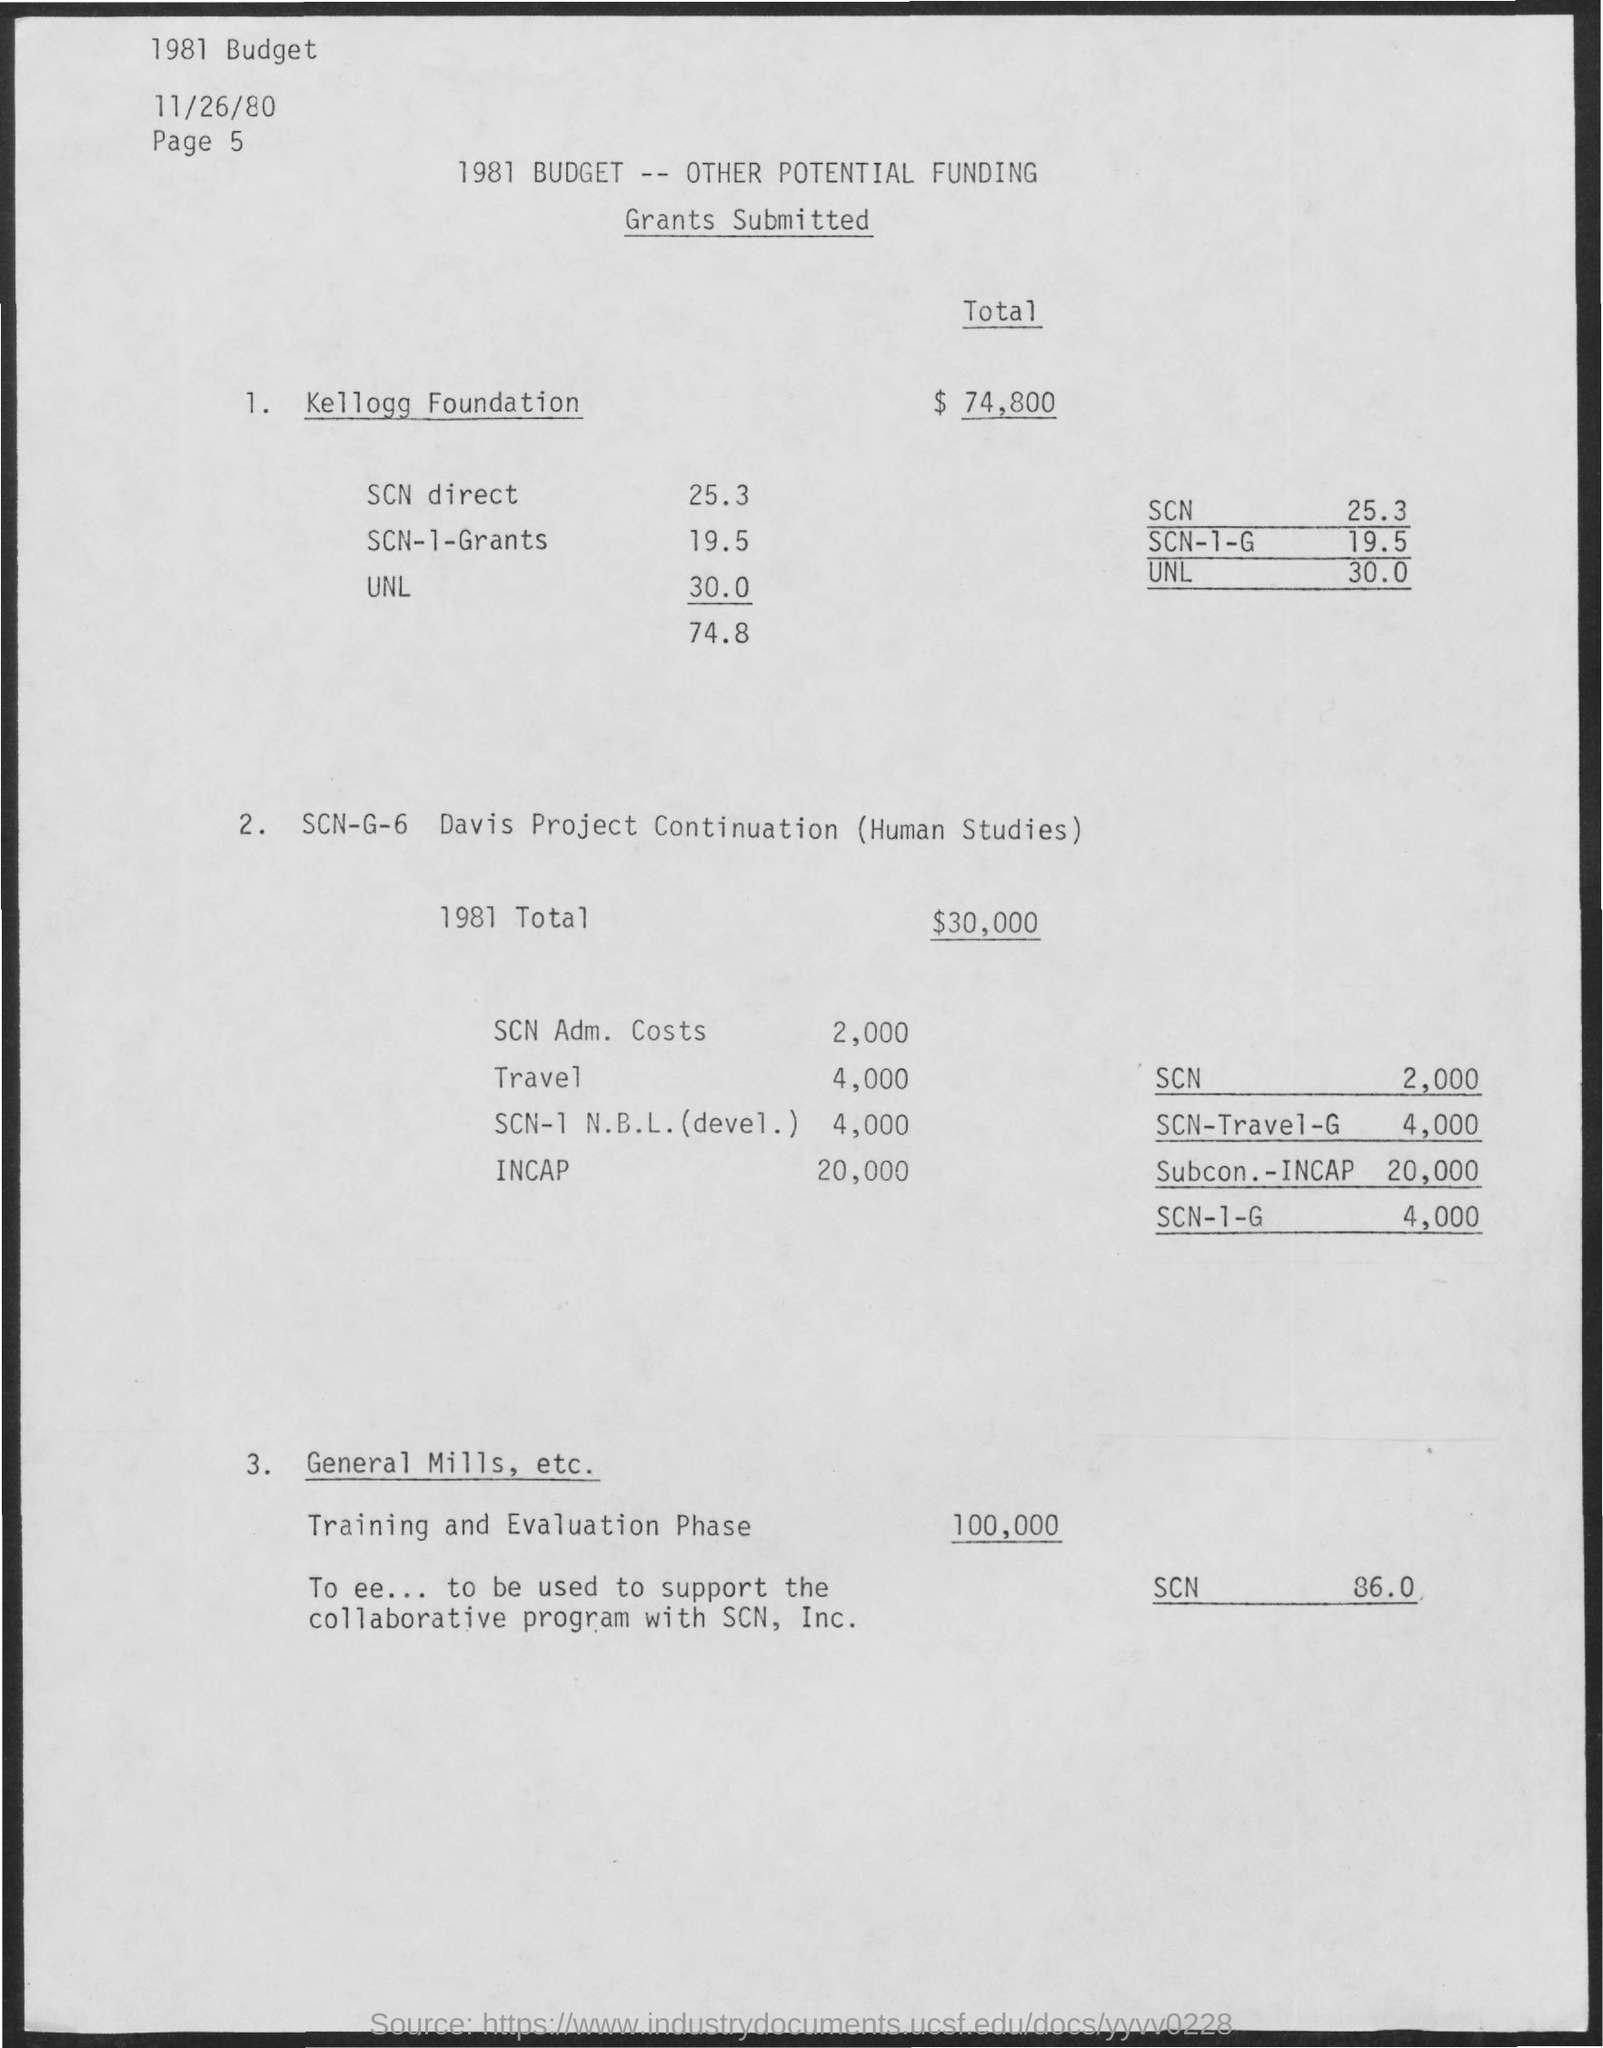Total fund for training and evaluation phase?
 100,000 